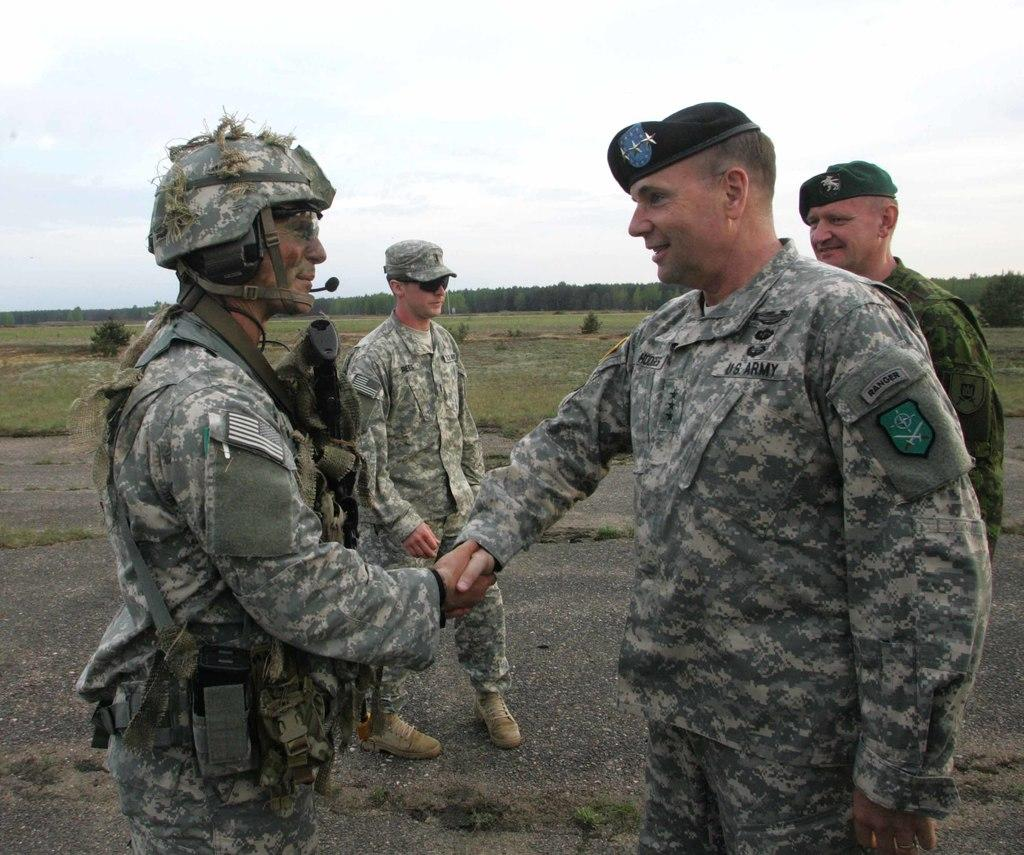What is the main subject in the center of the image? There are soldiers in the center of the image. What can be seen in the background of the image? There are trees in the background of the image. What type of vacation is the soldier planning in the image? There is no indication of a vacation in the image; it features soldiers in the center and trees in the background. 